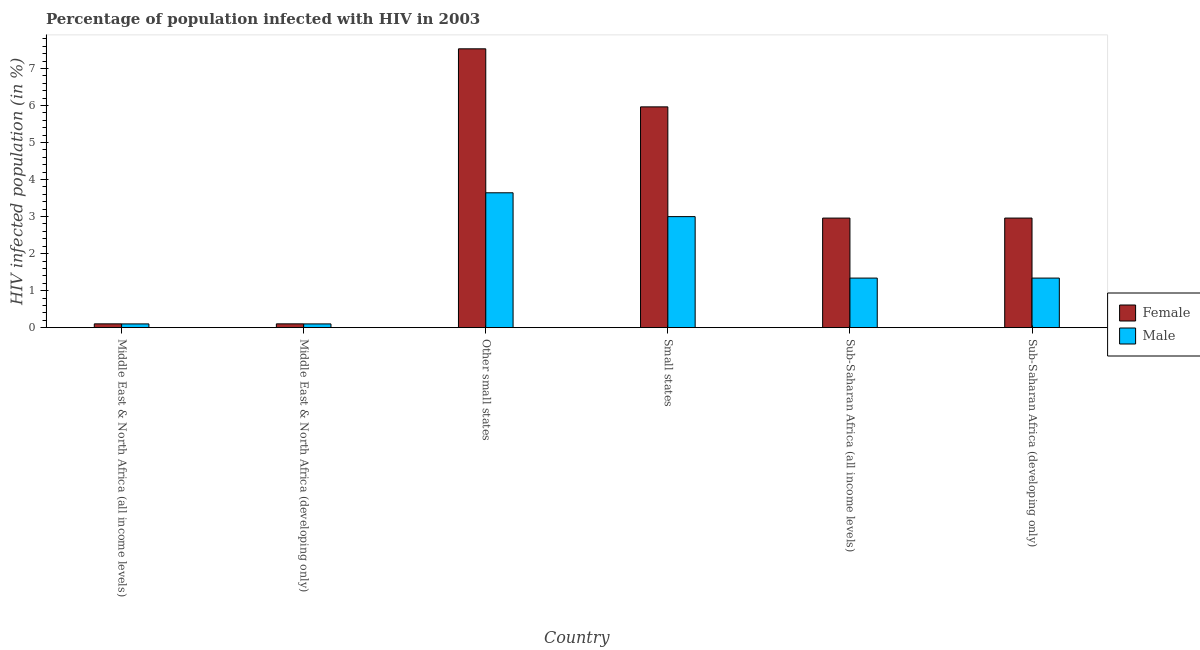How many groups of bars are there?
Make the answer very short. 6. Are the number of bars on each tick of the X-axis equal?
Provide a short and direct response. Yes. How many bars are there on the 5th tick from the left?
Provide a succinct answer. 2. What is the label of the 2nd group of bars from the left?
Your response must be concise. Middle East & North Africa (developing only). What is the percentage of males who are infected with hiv in Middle East & North Africa (all income levels)?
Provide a succinct answer. 0.1. Across all countries, what is the maximum percentage of males who are infected with hiv?
Provide a succinct answer. 3.64. Across all countries, what is the minimum percentage of females who are infected with hiv?
Provide a short and direct response. 0.1. In which country was the percentage of females who are infected with hiv maximum?
Offer a terse response. Other small states. In which country was the percentage of females who are infected with hiv minimum?
Your answer should be compact. Middle East & North Africa (all income levels). What is the total percentage of males who are infected with hiv in the graph?
Give a very brief answer. 9.52. What is the difference between the percentage of males who are infected with hiv in Other small states and that in Sub-Saharan Africa (all income levels)?
Offer a very short reply. 2.3. What is the difference between the percentage of males who are infected with hiv in Small states and the percentage of females who are infected with hiv in Middle East & North Africa (all income levels)?
Ensure brevity in your answer.  2.9. What is the average percentage of females who are infected with hiv per country?
Offer a very short reply. 3.27. What is the difference between the percentage of males who are infected with hiv and percentage of females who are infected with hiv in Sub-Saharan Africa (developing only)?
Provide a short and direct response. -1.62. In how many countries, is the percentage of males who are infected with hiv greater than 0.4 %?
Offer a very short reply. 4. What is the ratio of the percentage of males who are infected with hiv in Other small states to that in Small states?
Offer a very short reply. 1.21. Is the percentage of males who are infected with hiv in Middle East & North Africa (all income levels) less than that in Other small states?
Your response must be concise. Yes. Is the difference between the percentage of females who are infected with hiv in Middle East & North Africa (developing only) and Sub-Saharan Africa (all income levels) greater than the difference between the percentage of males who are infected with hiv in Middle East & North Africa (developing only) and Sub-Saharan Africa (all income levels)?
Make the answer very short. No. What is the difference between the highest and the second highest percentage of females who are infected with hiv?
Provide a succinct answer. 1.57. What is the difference between the highest and the lowest percentage of males who are infected with hiv?
Provide a succinct answer. 3.54. In how many countries, is the percentage of females who are infected with hiv greater than the average percentage of females who are infected with hiv taken over all countries?
Offer a terse response. 2. Is the sum of the percentage of males who are infected with hiv in Middle East & North Africa (developing only) and Other small states greater than the maximum percentage of females who are infected with hiv across all countries?
Give a very brief answer. No. How many countries are there in the graph?
Keep it short and to the point. 6. What is the difference between two consecutive major ticks on the Y-axis?
Keep it short and to the point. 1. Are the values on the major ticks of Y-axis written in scientific E-notation?
Your answer should be very brief. No. Does the graph contain grids?
Give a very brief answer. No. How are the legend labels stacked?
Offer a terse response. Vertical. What is the title of the graph?
Your answer should be compact. Percentage of population infected with HIV in 2003. Does "Excluding technical cooperation" appear as one of the legend labels in the graph?
Ensure brevity in your answer.  No. What is the label or title of the Y-axis?
Offer a very short reply. HIV infected population (in %). What is the HIV infected population (in %) of Female in Middle East & North Africa (all income levels)?
Offer a very short reply. 0.1. What is the HIV infected population (in %) of Male in Middle East & North Africa (all income levels)?
Provide a short and direct response. 0.1. What is the HIV infected population (in %) in Female in Middle East & North Africa (developing only)?
Provide a succinct answer. 0.1. What is the HIV infected population (in %) of Male in Middle East & North Africa (developing only)?
Provide a short and direct response. 0.1. What is the HIV infected population (in %) in Female in Other small states?
Provide a succinct answer. 7.53. What is the HIV infected population (in %) of Male in Other small states?
Offer a terse response. 3.64. What is the HIV infected population (in %) of Female in Small states?
Your response must be concise. 5.96. What is the HIV infected population (in %) of Male in Small states?
Your response must be concise. 3. What is the HIV infected population (in %) of Female in Sub-Saharan Africa (all income levels)?
Ensure brevity in your answer.  2.96. What is the HIV infected population (in %) in Male in Sub-Saharan Africa (all income levels)?
Provide a short and direct response. 1.34. What is the HIV infected population (in %) in Female in Sub-Saharan Africa (developing only)?
Your answer should be very brief. 2.96. What is the HIV infected population (in %) in Male in Sub-Saharan Africa (developing only)?
Offer a terse response. 1.34. Across all countries, what is the maximum HIV infected population (in %) in Female?
Give a very brief answer. 7.53. Across all countries, what is the maximum HIV infected population (in %) in Male?
Give a very brief answer. 3.64. Across all countries, what is the minimum HIV infected population (in %) of Female?
Give a very brief answer. 0.1. Across all countries, what is the minimum HIV infected population (in %) in Male?
Make the answer very short. 0.1. What is the total HIV infected population (in %) of Female in the graph?
Make the answer very short. 19.62. What is the total HIV infected population (in %) in Male in the graph?
Keep it short and to the point. 9.52. What is the difference between the HIV infected population (in %) in Male in Middle East & North Africa (all income levels) and that in Middle East & North Africa (developing only)?
Provide a short and direct response. -0. What is the difference between the HIV infected population (in %) of Female in Middle East & North Africa (all income levels) and that in Other small states?
Your response must be concise. -7.43. What is the difference between the HIV infected population (in %) of Male in Middle East & North Africa (all income levels) and that in Other small states?
Your answer should be compact. -3.54. What is the difference between the HIV infected population (in %) in Female in Middle East & North Africa (all income levels) and that in Small states?
Make the answer very short. -5.86. What is the difference between the HIV infected population (in %) in Male in Middle East & North Africa (all income levels) and that in Small states?
Offer a very short reply. -2.9. What is the difference between the HIV infected population (in %) in Female in Middle East & North Africa (all income levels) and that in Sub-Saharan Africa (all income levels)?
Your response must be concise. -2.86. What is the difference between the HIV infected population (in %) in Male in Middle East & North Africa (all income levels) and that in Sub-Saharan Africa (all income levels)?
Provide a short and direct response. -1.24. What is the difference between the HIV infected population (in %) in Female in Middle East & North Africa (all income levels) and that in Sub-Saharan Africa (developing only)?
Keep it short and to the point. -2.86. What is the difference between the HIV infected population (in %) of Male in Middle East & North Africa (all income levels) and that in Sub-Saharan Africa (developing only)?
Offer a terse response. -1.24. What is the difference between the HIV infected population (in %) in Female in Middle East & North Africa (developing only) and that in Other small states?
Offer a terse response. -7.43. What is the difference between the HIV infected population (in %) in Male in Middle East & North Africa (developing only) and that in Other small states?
Ensure brevity in your answer.  -3.54. What is the difference between the HIV infected population (in %) in Female in Middle East & North Africa (developing only) and that in Small states?
Your answer should be compact. -5.86. What is the difference between the HIV infected population (in %) of Male in Middle East & North Africa (developing only) and that in Small states?
Your answer should be very brief. -2.9. What is the difference between the HIV infected population (in %) in Female in Middle East & North Africa (developing only) and that in Sub-Saharan Africa (all income levels)?
Your response must be concise. -2.86. What is the difference between the HIV infected population (in %) of Male in Middle East & North Africa (developing only) and that in Sub-Saharan Africa (all income levels)?
Your answer should be very brief. -1.24. What is the difference between the HIV infected population (in %) of Female in Middle East & North Africa (developing only) and that in Sub-Saharan Africa (developing only)?
Ensure brevity in your answer.  -2.86. What is the difference between the HIV infected population (in %) of Male in Middle East & North Africa (developing only) and that in Sub-Saharan Africa (developing only)?
Ensure brevity in your answer.  -1.24. What is the difference between the HIV infected population (in %) of Female in Other small states and that in Small states?
Provide a short and direct response. 1.57. What is the difference between the HIV infected population (in %) of Male in Other small states and that in Small states?
Your answer should be very brief. 0.64. What is the difference between the HIV infected population (in %) in Female in Other small states and that in Sub-Saharan Africa (all income levels)?
Your answer should be compact. 4.57. What is the difference between the HIV infected population (in %) of Male in Other small states and that in Sub-Saharan Africa (all income levels)?
Your answer should be compact. 2.3. What is the difference between the HIV infected population (in %) in Female in Other small states and that in Sub-Saharan Africa (developing only)?
Your answer should be very brief. 4.57. What is the difference between the HIV infected population (in %) in Male in Other small states and that in Sub-Saharan Africa (developing only)?
Your answer should be compact. 2.3. What is the difference between the HIV infected population (in %) of Female in Small states and that in Sub-Saharan Africa (all income levels)?
Make the answer very short. 3. What is the difference between the HIV infected population (in %) of Male in Small states and that in Sub-Saharan Africa (all income levels)?
Provide a succinct answer. 1.66. What is the difference between the HIV infected population (in %) of Female in Small states and that in Sub-Saharan Africa (developing only)?
Your answer should be very brief. 3. What is the difference between the HIV infected population (in %) of Male in Small states and that in Sub-Saharan Africa (developing only)?
Provide a short and direct response. 1.66. What is the difference between the HIV infected population (in %) in Female in Sub-Saharan Africa (all income levels) and that in Sub-Saharan Africa (developing only)?
Ensure brevity in your answer.  -0. What is the difference between the HIV infected population (in %) in Male in Sub-Saharan Africa (all income levels) and that in Sub-Saharan Africa (developing only)?
Give a very brief answer. -0. What is the difference between the HIV infected population (in %) of Female in Middle East & North Africa (all income levels) and the HIV infected population (in %) of Male in Middle East & North Africa (developing only)?
Provide a short and direct response. 0. What is the difference between the HIV infected population (in %) of Female in Middle East & North Africa (all income levels) and the HIV infected population (in %) of Male in Other small states?
Your answer should be compact. -3.54. What is the difference between the HIV infected population (in %) in Female in Middle East & North Africa (all income levels) and the HIV infected population (in %) in Male in Small states?
Ensure brevity in your answer.  -2.9. What is the difference between the HIV infected population (in %) of Female in Middle East & North Africa (all income levels) and the HIV infected population (in %) of Male in Sub-Saharan Africa (all income levels)?
Provide a succinct answer. -1.24. What is the difference between the HIV infected population (in %) of Female in Middle East & North Africa (all income levels) and the HIV infected population (in %) of Male in Sub-Saharan Africa (developing only)?
Offer a very short reply. -1.24. What is the difference between the HIV infected population (in %) in Female in Middle East & North Africa (developing only) and the HIV infected population (in %) in Male in Other small states?
Provide a short and direct response. -3.54. What is the difference between the HIV infected population (in %) of Female in Middle East & North Africa (developing only) and the HIV infected population (in %) of Male in Small states?
Your response must be concise. -2.9. What is the difference between the HIV infected population (in %) of Female in Middle East & North Africa (developing only) and the HIV infected population (in %) of Male in Sub-Saharan Africa (all income levels)?
Provide a succinct answer. -1.24. What is the difference between the HIV infected population (in %) in Female in Middle East & North Africa (developing only) and the HIV infected population (in %) in Male in Sub-Saharan Africa (developing only)?
Ensure brevity in your answer.  -1.24. What is the difference between the HIV infected population (in %) of Female in Other small states and the HIV infected population (in %) of Male in Small states?
Give a very brief answer. 4.53. What is the difference between the HIV infected population (in %) in Female in Other small states and the HIV infected population (in %) in Male in Sub-Saharan Africa (all income levels)?
Give a very brief answer. 6.19. What is the difference between the HIV infected population (in %) of Female in Other small states and the HIV infected population (in %) of Male in Sub-Saharan Africa (developing only)?
Your answer should be very brief. 6.19. What is the difference between the HIV infected population (in %) in Female in Small states and the HIV infected population (in %) in Male in Sub-Saharan Africa (all income levels)?
Your answer should be very brief. 4.62. What is the difference between the HIV infected population (in %) in Female in Small states and the HIV infected population (in %) in Male in Sub-Saharan Africa (developing only)?
Provide a succinct answer. 4.62. What is the difference between the HIV infected population (in %) in Female in Sub-Saharan Africa (all income levels) and the HIV infected population (in %) in Male in Sub-Saharan Africa (developing only)?
Your response must be concise. 1.62. What is the average HIV infected population (in %) of Female per country?
Your answer should be compact. 3.27. What is the average HIV infected population (in %) of Male per country?
Keep it short and to the point. 1.59. What is the difference between the HIV infected population (in %) in Female and HIV infected population (in %) in Male in Middle East & North Africa (all income levels)?
Provide a short and direct response. 0. What is the difference between the HIV infected population (in %) in Female and HIV infected population (in %) in Male in Middle East & North Africa (developing only)?
Provide a succinct answer. 0. What is the difference between the HIV infected population (in %) of Female and HIV infected population (in %) of Male in Other small states?
Your response must be concise. 3.89. What is the difference between the HIV infected population (in %) of Female and HIV infected population (in %) of Male in Small states?
Ensure brevity in your answer.  2.96. What is the difference between the HIV infected population (in %) of Female and HIV infected population (in %) of Male in Sub-Saharan Africa (all income levels)?
Offer a very short reply. 1.62. What is the difference between the HIV infected population (in %) in Female and HIV infected population (in %) in Male in Sub-Saharan Africa (developing only)?
Give a very brief answer. 1.62. What is the ratio of the HIV infected population (in %) of Female in Middle East & North Africa (all income levels) to that in Other small states?
Give a very brief answer. 0.01. What is the ratio of the HIV infected population (in %) in Male in Middle East & North Africa (all income levels) to that in Other small states?
Make the answer very short. 0.03. What is the ratio of the HIV infected population (in %) in Female in Middle East & North Africa (all income levels) to that in Small states?
Give a very brief answer. 0.02. What is the ratio of the HIV infected population (in %) in Male in Middle East & North Africa (all income levels) to that in Small states?
Ensure brevity in your answer.  0.03. What is the ratio of the HIV infected population (in %) of Female in Middle East & North Africa (all income levels) to that in Sub-Saharan Africa (all income levels)?
Make the answer very short. 0.03. What is the ratio of the HIV infected population (in %) of Male in Middle East & North Africa (all income levels) to that in Sub-Saharan Africa (all income levels)?
Make the answer very short. 0.08. What is the ratio of the HIV infected population (in %) of Female in Middle East & North Africa (all income levels) to that in Sub-Saharan Africa (developing only)?
Offer a very short reply. 0.03. What is the ratio of the HIV infected population (in %) of Male in Middle East & North Africa (all income levels) to that in Sub-Saharan Africa (developing only)?
Provide a short and direct response. 0.08. What is the ratio of the HIV infected population (in %) of Female in Middle East & North Africa (developing only) to that in Other small states?
Your answer should be compact. 0.01. What is the ratio of the HIV infected population (in %) in Male in Middle East & North Africa (developing only) to that in Other small states?
Offer a terse response. 0.03. What is the ratio of the HIV infected population (in %) in Female in Middle East & North Africa (developing only) to that in Small states?
Provide a short and direct response. 0.02. What is the ratio of the HIV infected population (in %) in Male in Middle East & North Africa (developing only) to that in Small states?
Offer a terse response. 0.03. What is the ratio of the HIV infected population (in %) in Female in Middle East & North Africa (developing only) to that in Sub-Saharan Africa (all income levels)?
Provide a short and direct response. 0.03. What is the ratio of the HIV infected population (in %) of Male in Middle East & North Africa (developing only) to that in Sub-Saharan Africa (all income levels)?
Your answer should be very brief. 0.08. What is the ratio of the HIV infected population (in %) in Female in Middle East & North Africa (developing only) to that in Sub-Saharan Africa (developing only)?
Offer a very short reply. 0.03. What is the ratio of the HIV infected population (in %) in Male in Middle East & North Africa (developing only) to that in Sub-Saharan Africa (developing only)?
Offer a very short reply. 0.08. What is the ratio of the HIV infected population (in %) in Female in Other small states to that in Small states?
Provide a short and direct response. 1.26. What is the ratio of the HIV infected population (in %) of Male in Other small states to that in Small states?
Offer a very short reply. 1.21. What is the ratio of the HIV infected population (in %) in Female in Other small states to that in Sub-Saharan Africa (all income levels)?
Keep it short and to the point. 2.54. What is the ratio of the HIV infected population (in %) of Male in Other small states to that in Sub-Saharan Africa (all income levels)?
Offer a very short reply. 2.72. What is the ratio of the HIV infected population (in %) of Female in Other small states to that in Sub-Saharan Africa (developing only)?
Your answer should be compact. 2.54. What is the ratio of the HIV infected population (in %) in Male in Other small states to that in Sub-Saharan Africa (developing only)?
Provide a short and direct response. 2.72. What is the ratio of the HIV infected population (in %) in Female in Small states to that in Sub-Saharan Africa (all income levels)?
Your answer should be very brief. 2.02. What is the ratio of the HIV infected population (in %) in Male in Small states to that in Sub-Saharan Africa (all income levels)?
Make the answer very short. 2.24. What is the ratio of the HIV infected population (in %) in Female in Small states to that in Sub-Saharan Africa (developing only)?
Your answer should be very brief. 2.01. What is the ratio of the HIV infected population (in %) in Male in Small states to that in Sub-Saharan Africa (developing only)?
Your answer should be very brief. 2.24. What is the difference between the highest and the second highest HIV infected population (in %) of Female?
Ensure brevity in your answer.  1.57. What is the difference between the highest and the second highest HIV infected population (in %) in Male?
Your answer should be very brief. 0.64. What is the difference between the highest and the lowest HIV infected population (in %) in Female?
Provide a succinct answer. 7.43. What is the difference between the highest and the lowest HIV infected population (in %) of Male?
Your response must be concise. 3.54. 